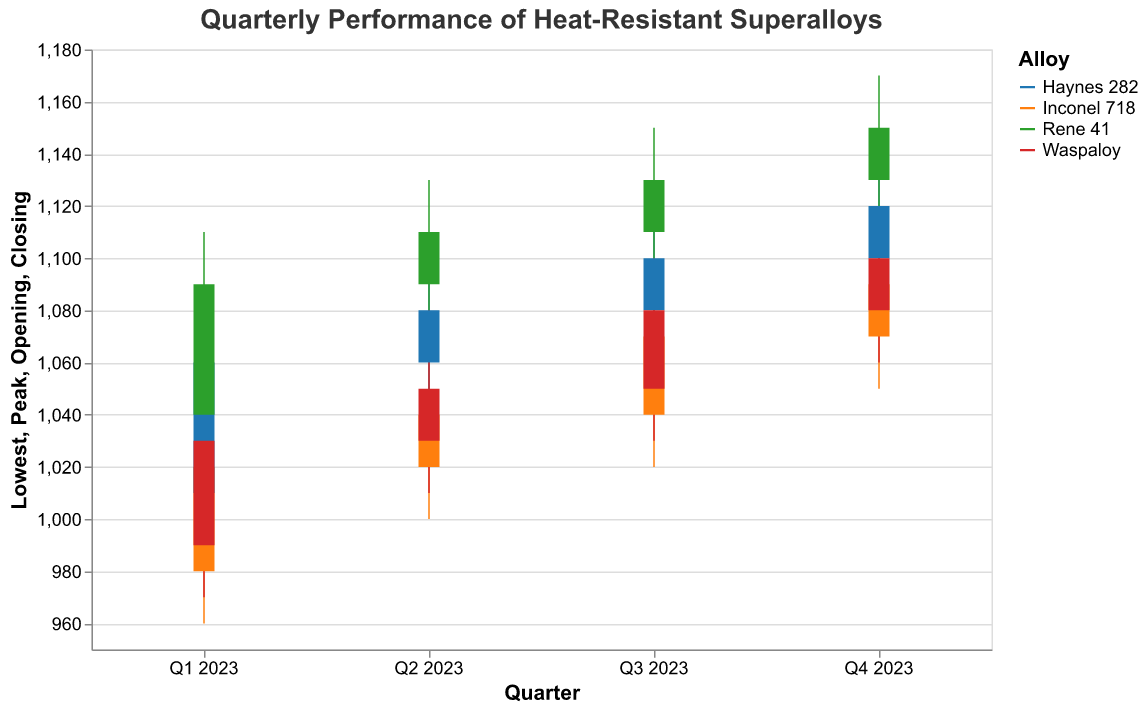What is the title of the chart? The title is usually displayed at the top of the chart. In this case, it is "Quarterly Performance of Heat-Resistant Superalloys".
Answer: Quarterly Performance of Heat-Resistant Superalloys Which quarter and alloy exhibit the highest peak temperature tolerance? From the chart, we can look for the highest peak value across all quarters and alloys. Rene 41 in Q4 2023 has a peak temperature tolerance of 1170°C.
Answer: Q4 2023, Rene 41 During which quarter did Inconel 718 have the lowest opening temperature? By examining the opening temperatures of Inconel 718 across all quarters, Q1 2023 stands out with an opening temperature of 980°C.
Answer: Q1 2023 What is the difference between the lowest and peak temperature tolerances for Haynes 282 in Q2 2023? For Haynes 282 in Q2 2023, the lowest temperature is 1040°C and the peak is 1100°C. The difference is 1100 - 1040 = 60°C.
Answer: 60°C Which alloy had the highest closing temperature in Q3 2023? By comparing closing temperatures of all alloys in Q3 2023, Rene 41 has the highest closing temperature at 1130°C.
Answer: Rene 41 What can be inferred about Waspaloy's performance trend across the quarters? Observing Waspaloy's data points across Q1 to Q4 2023, there is a general upward trend in both opening and closing temperatures, indicating improved performance.
Answer: Upward trend Which quarter shows the most significant increase in Haynes 282's closing temperature compared to the previous quarter? Comparing closing temperatures for Haynes 282: Q2 (1080°C), Q3 (1100°C), and Q4 (1120°C). The most significant increase is from Q1 (1060°C) to Q2 (1080°C), which is 20°C.
Answer: Q2 2023 How does the performance of Inconel 718 in Q4 2023 compare with its performance in Q1 2023? In Q4, Inconel 718 has higher opening (1070°C vs. 980°C), peak (1110°C vs. 1050°C), lowest (1050°C vs. 960°C), and closing (1090°C vs. 1020°C) temperatures compared to Q1 2023. This shows an overall improvement.
Answer: Improved What is the average peak temperature across all alloys in Q2 2023? The peaks in Q2 2023 are: Inconel 718 (1070°C), Haynes 282 (1100°C), Rene 41 (1130°C), Waspaloy (1080°C). The average is (1070 + 1100 + 1130 + 1080) / 4 = 1095°C.
Answer: 1095°C Which alloy shows the most stable performance between Q1 and Q4 2023, based on the difference between opening and closing temperatures? Stability can be judged by the smallest difference between opening and closing temperatures. Inconel 718 shows consistent differences (~40°C) whereas others vary more significantly.
Answer: Inconel 718 